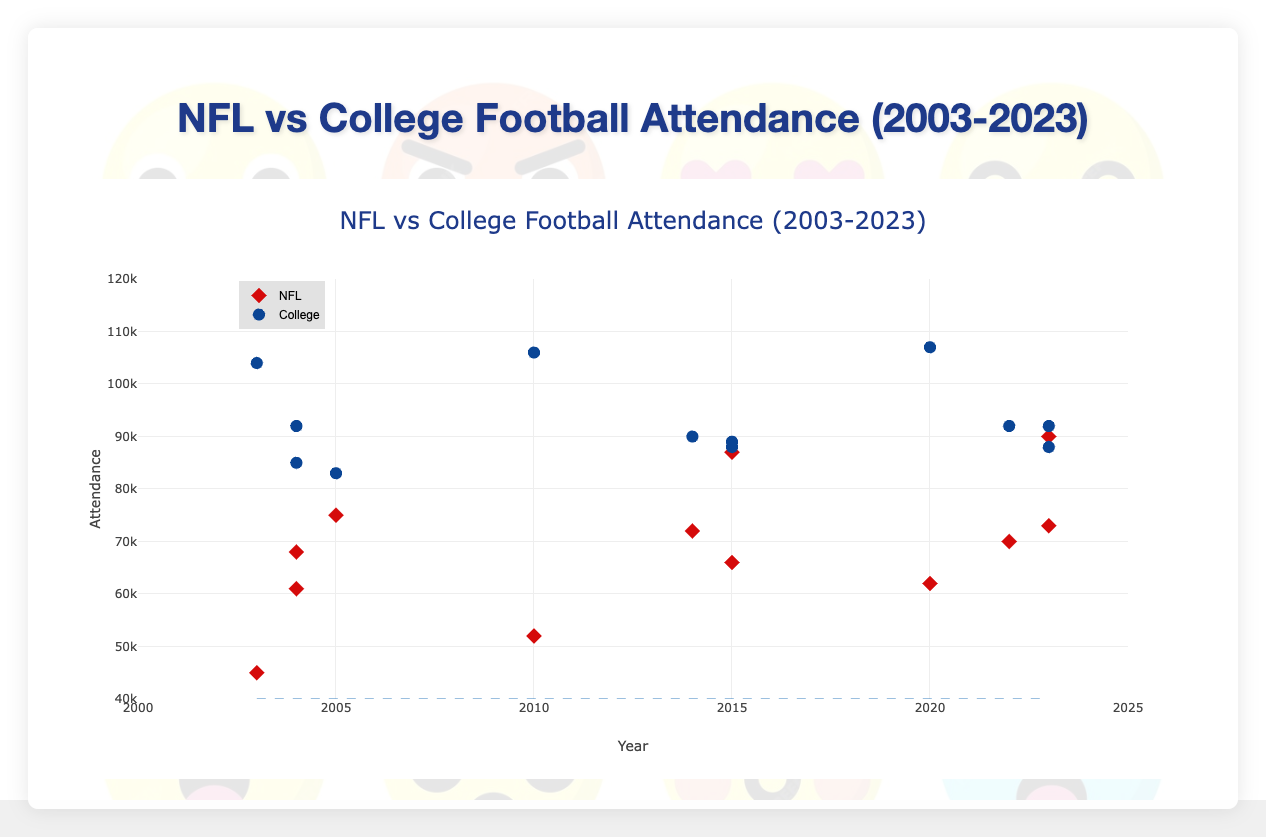What's the title of the figure? The title of the figure is clearly displayed at the top of the plot.
Answer: NFL vs College Football Attendance (2003-2023) How many data points represent NFL attendance? The NFL data points can be counted by identifying the points marked as 'NFL' in the legend and on the plot. There are 12 such points.
Answer: 12 Which has higher attendance on average, NFL or college football? Calculate the average attendance for each group. NFL: (45000 + 52000 + 62000 + 75000 + 87000 + 90000 + 68000 + 72000 + 73000 + 61000 + 66000 + 70000) / 12 = 69583.33. College: (104000 + 106000 + 107000 + 83000 + 89000 + 92000 + 92000 + 90000 + 88000 + 85000 + 88000 + 92000) / 12 = 94250.
Answer: College football How did attendance for the Cincinnati Bengals change over the years? The Cincinnati Bengals data points can be identified and compared for different years: 2003 (45000), 2010 (52000), and 2020 (62000). The attendance shows an increasing trend.
Answer: Increased Which state has the highest average attendance for college football? Calculate the average attendance for each state's college football teams: Ohio: (104000 + 106000 + 107000) / 3 = 105666.67, Texas: (83000 + 89000 + 92000) / 3 = 88000, California: (92000 + 90000 + 88000) / 3 = 90000, Florida: (85000 + 88000 + 92000) / 3 = 88333.33. Ohio has the highest average.
Answer: Ohio Compare the attendance trend for NFL and college football in Texas over the years shown. Texas NFL (Dallas Cowboys): 2005 (75000), 2015 (87000), 2023 (90000). Texas College (Texas Longhorns): 2005 (83000), 2015 (89000), 2023 (92000). Both NFL and college football attendance in Texas have increased over the years, with college football starting at a higher base and increasing slightly more.
Answer: Both increased What is the difference in attendance for Ohio State Buckeyes between 2003 and 2020? Attendance for Ohio State Buckeyes in 2003 is 104000, and in 2020, it is 107000. The difference is 107000 - 104000.
Answer: 3000 Which team has the lowest attendance among all the data points? Find the minimum attendance value from all data points. The lowest attendance recorded is for the Cincinnati Bengals in 2003 with 45000 attendees.
Answer: Cincinnati Bengals (45000) In which year did the Dallas Cowboys have the highest attendance? The attendance data for the Dallas Cowboys should be checked year by year: 2005 (75000), 2015 (87000), 2023 (90000). The highest attendance is in 2023.
Answer: 2023 How does the attendance for USC Trojans change over the three years shown? USC Trojans data points: 2004 (92000), 2014 (90000), 2023 (88000). The attendance shows a decreasing trend over the years.
Answer: Decreased 